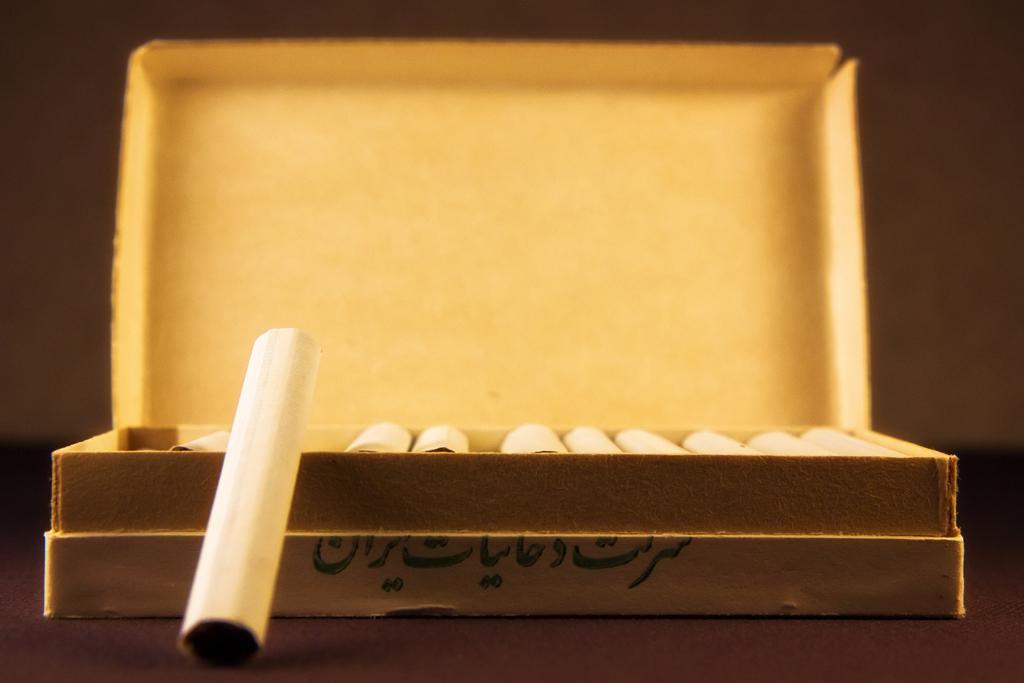Can you describe this image briefly? In this picture we can see a box, there are some rolled papers in the box, we can see a blurry background. 